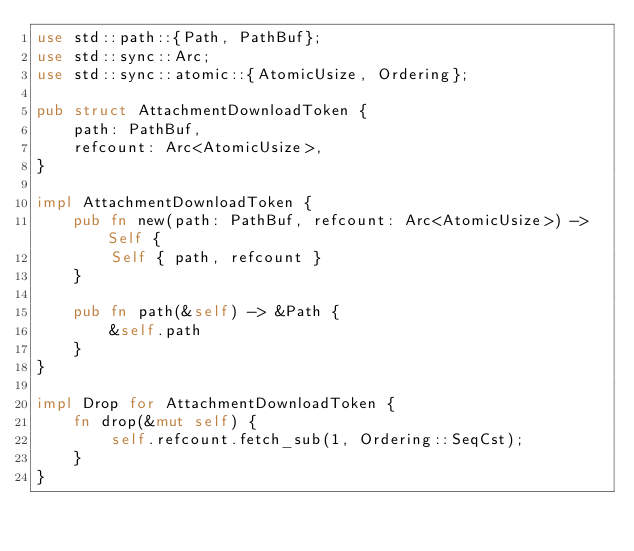<code> <loc_0><loc_0><loc_500><loc_500><_Rust_>use std::path::{Path, PathBuf};
use std::sync::Arc;
use std::sync::atomic::{AtomicUsize, Ordering};

pub struct AttachmentDownloadToken {
    path: PathBuf,
    refcount: Arc<AtomicUsize>,
}

impl AttachmentDownloadToken {
    pub fn new(path: PathBuf, refcount: Arc<AtomicUsize>) -> Self {
        Self { path, refcount }
    }

    pub fn path(&self) -> &Path {
        &self.path
    }
}

impl Drop for AttachmentDownloadToken {
    fn drop(&mut self) {
        self.refcount.fetch_sub(1, Ordering::SeqCst);
    }
}</code> 